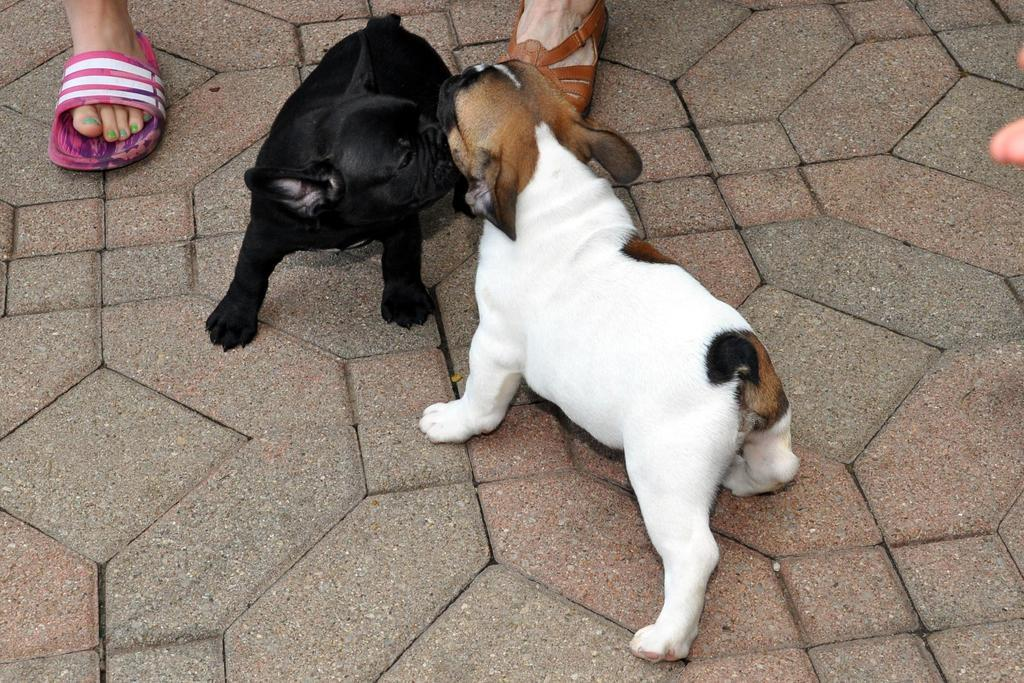What type of animals are in the image? There is a white dog and a black dog in the image. What are the dogs doing in the image? The dogs are playing on the street. Can you describe anything in the background of the image? In the background, there are two legs of different people visible. Where is the sheep located in the image? There is no sheep present in the image. What type of station is visible in the background of the image? There is no station visible in the background of the image. 